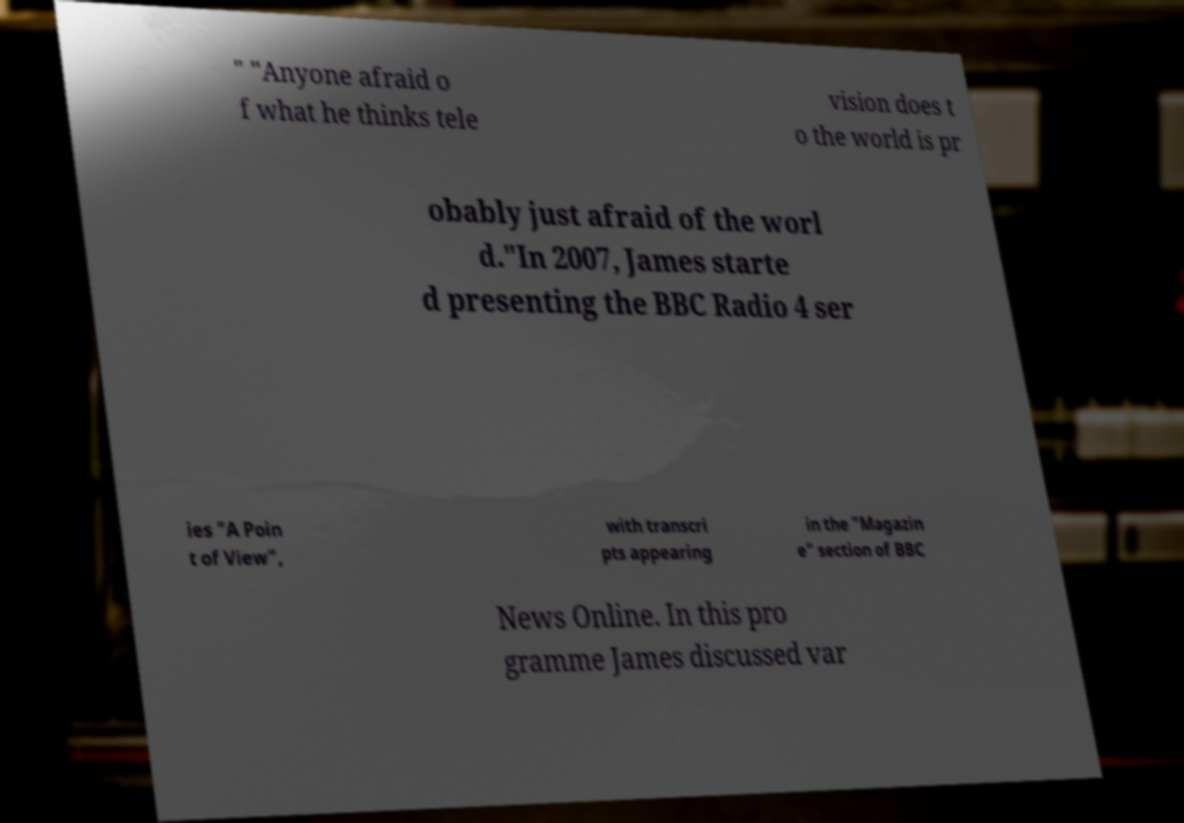I need the written content from this picture converted into text. Can you do that? " "Anyone afraid o f what he thinks tele vision does t o the world is pr obably just afraid of the worl d."In 2007, James starte d presenting the BBC Radio 4 ser ies "A Poin t of View", with transcri pts appearing in the "Magazin e" section of BBC News Online. In this pro gramme James discussed var 